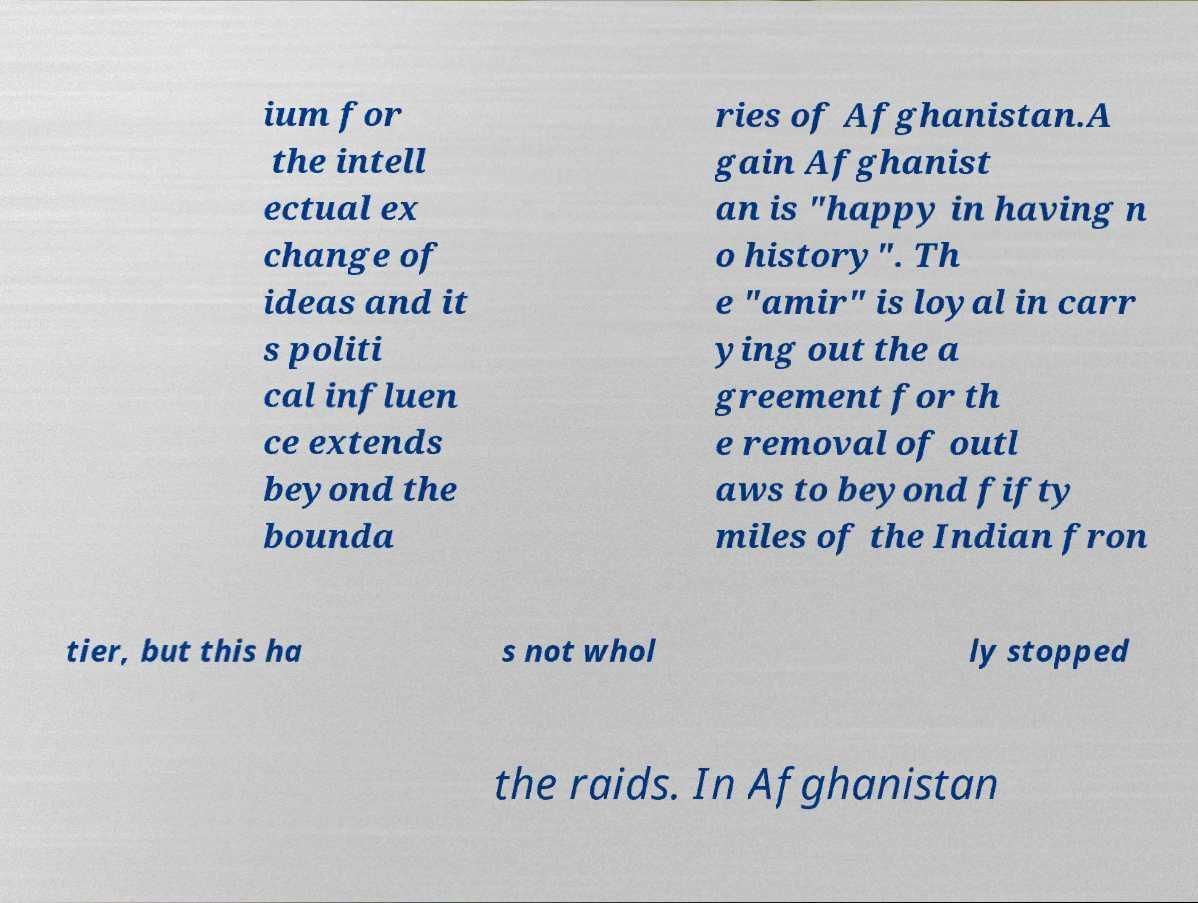Can you accurately transcribe the text from the provided image for me? ium for the intell ectual ex change of ideas and it s politi cal influen ce extends beyond the bounda ries of Afghanistan.A gain Afghanist an is "happy in having n o history". Th e "amir" is loyal in carr ying out the a greement for th e removal of outl aws to beyond fifty miles of the Indian fron tier, but this ha s not whol ly stopped the raids. In Afghanistan 